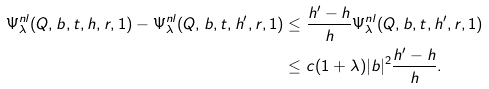Convert formula to latex. <formula><loc_0><loc_0><loc_500><loc_500>\Psi _ { \lambda } ^ { n l } ( Q , b , t , h , r , 1 ) - \Psi _ { \lambda } ^ { n l } ( Q , b , t , h ^ { \prime } , r , 1 ) & \leq \frac { h ^ { \prime } - h } { h } \Psi _ { \lambda } ^ { n l } ( Q , b , t , h ^ { \prime } , r , 1 ) \\ & \leq c ( 1 + \lambda ) | b | ^ { 2 } \frac { h ^ { \prime } - h } { h } .</formula> 